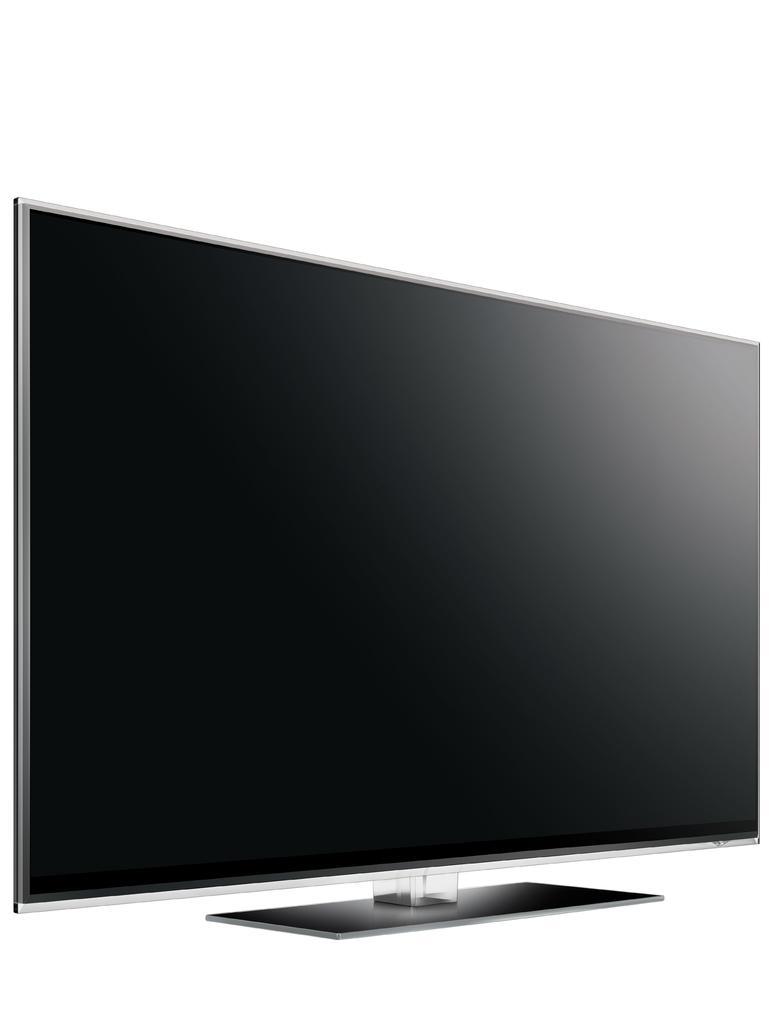Can you describe this image briefly? Here in this picture we can see a television present over there. 